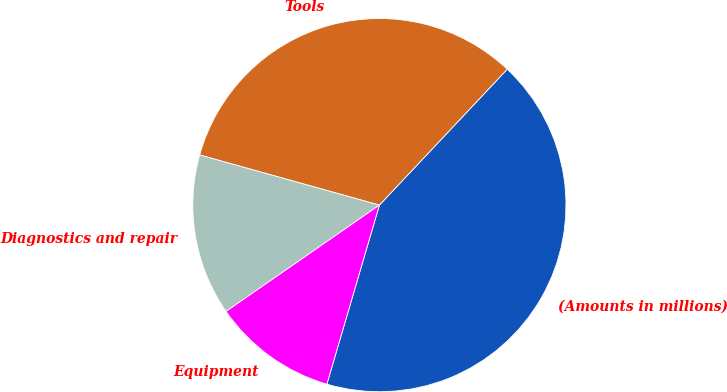<chart> <loc_0><loc_0><loc_500><loc_500><pie_chart><fcel>(Amounts in millions)<fcel>Tools<fcel>Diagnostics and repair<fcel>Equipment<nl><fcel>42.53%<fcel>32.69%<fcel>13.98%<fcel>10.81%<nl></chart> 